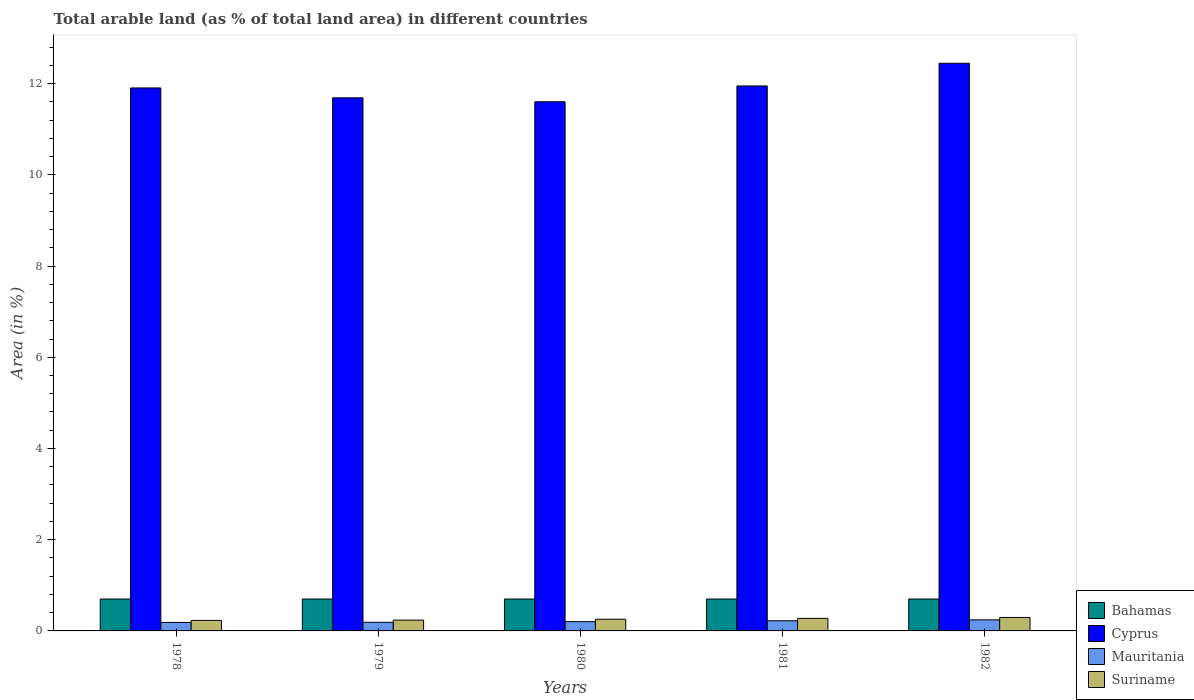How many different coloured bars are there?
Your answer should be very brief. 4. How many bars are there on the 2nd tick from the left?
Ensure brevity in your answer.  4. How many bars are there on the 5th tick from the right?
Your response must be concise. 4. What is the percentage of arable land in Bahamas in 1978?
Provide a succinct answer. 0.7. Across all years, what is the maximum percentage of arable land in Suriname?
Provide a succinct answer. 0.29. Across all years, what is the minimum percentage of arable land in Mauritania?
Your answer should be compact. 0.19. In which year was the percentage of arable land in Mauritania minimum?
Offer a very short reply. 1978. What is the total percentage of arable land in Mauritania in the graph?
Offer a terse response. 1.04. What is the difference between the percentage of arable land in Cyprus in 1979 and that in 1982?
Give a very brief answer. -0.76. What is the difference between the percentage of arable land in Cyprus in 1982 and the percentage of arable land in Mauritania in 1978?
Ensure brevity in your answer.  12.26. What is the average percentage of arable land in Mauritania per year?
Give a very brief answer. 0.21. In the year 1980, what is the difference between the percentage of arable land in Suriname and percentage of arable land in Bahamas?
Your response must be concise. -0.44. What is the difference between the highest and the second highest percentage of arable land in Cyprus?
Your answer should be compact. 0.5. What is the difference between the highest and the lowest percentage of arable land in Bahamas?
Give a very brief answer. 0. Is it the case that in every year, the sum of the percentage of arable land in Bahamas and percentage of arable land in Cyprus is greater than the sum of percentage of arable land in Suriname and percentage of arable land in Mauritania?
Keep it short and to the point. Yes. What does the 2nd bar from the left in 1982 represents?
Provide a short and direct response. Cyprus. What does the 1st bar from the right in 1982 represents?
Your response must be concise. Suriname. Is it the case that in every year, the sum of the percentage of arable land in Suriname and percentage of arable land in Mauritania is greater than the percentage of arable land in Bahamas?
Your response must be concise. No. How many years are there in the graph?
Give a very brief answer. 5. What is the difference between two consecutive major ticks on the Y-axis?
Make the answer very short. 2. Does the graph contain grids?
Your answer should be very brief. No. How many legend labels are there?
Give a very brief answer. 4. How are the legend labels stacked?
Your response must be concise. Vertical. What is the title of the graph?
Provide a short and direct response. Total arable land (as % of total land area) in different countries. What is the label or title of the Y-axis?
Provide a succinct answer. Area (in %). What is the Area (in %) in Bahamas in 1978?
Keep it short and to the point. 0.7. What is the Area (in %) of Cyprus in 1978?
Keep it short and to the point. 11.9. What is the Area (in %) of Mauritania in 1978?
Give a very brief answer. 0.19. What is the Area (in %) in Suriname in 1978?
Provide a succinct answer. 0.23. What is the Area (in %) in Bahamas in 1979?
Your answer should be compact. 0.7. What is the Area (in %) in Cyprus in 1979?
Your answer should be compact. 11.69. What is the Area (in %) of Mauritania in 1979?
Keep it short and to the point. 0.19. What is the Area (in %) in Suriname in 1979?
Your response must be concise. 0.24. What is the Area (in %) of Bahamas in 1980?
Keep it short and to the point. 0.7. What is the Area (in %) of Cyprus in 1980?
Provide a succinct answer. 11.6. What is the Area (in %) in Mauritania in 1980?
Ensure brevity in your answer.  0.2. What is the Area (in %) of Suriname in 1980?
Ensure brevity in your answer.  0.26. What is the Area (in %) of Bahamas in 1981?
Ensure brevity in your answer.  0.7. What is the Area (in %) in Cyprus in 1981?
Your answer should be compact. 11.95. What is the Area (in %) of Mauritania in 1981?
Ensure brevity in your answer.  0.22. What is the Area (in %) of Suriname in 1981?
Make the answer very short. 0.28. What is the Area (in %) of Bahamas in 1982?
Provide a short and direct response. 0.7. What is the Area (in %) of Cyprus in 1982?
Offer a very short reply. 12.45. What is the Area (in %) of Mauritania in 1982?
Your response must be concise. 0.24. What is the Area (in %) of Suriname in 1982?
Keep it short and to the point. 0.29. Across all years, what is the maximum Area (in %) of Bahamas?
Give a very brief answer. 0.7. Across all years, what is the maximum Area (in %) in Cyprus?
Your response must be concise. 12.45. Across all years, what is the maximum Area (in %) in Mauritania?
Your answer should be very brief. 0.24. Across all years, what is the maximum Area (in %) in Suriname?
Offer a terse response. 0.29. Across all years, what is the minimum Area (in %) of Bahamas?
Your answer should be very brief. 0.7. Across all years, what is the minimum Area (in %) of Cyprus?
Offer a terse response. 11.6. Across all years, what is the minimum Area (in %) in Mauritania?
Keep it short and to the point. 0.19. Across all years, what is the minimum Area (in %) in Suriname?
Your answer should be very brief. 0.23. What is the total Area (in %) in Bahamas in the graph?
Make the answer very short. 3.5. What is the total Area (in %) in Cyprus in the graph?
Offer a terse response. 59.59. What is the total Area (in %) of Mauritania in the graph?
Keep it short and to the point. 1.04. What is the total Area (in %) of Suriname in the graph?
Give a very brief answer. 1.29. What is the difference between the Area (in %) in Cyprus in 1978 and that in 1979?
Ensure brevity in your answer.  0.22. What is the difference between the Area (in %) in Mauritania in 1978 and that in 1979?
Make the answer very short. -0. What is the difference between the Area (in %) of Suriname in 1978 and that in 1979?
Make the answer very short. -0.01. What is the difference between the Area (in %) of Bahamas in 1978 and that in 1980?
Ensure brevity in your answer.  0. What is the difference between the Area (in %) in Cyprus in 1978 and that in 1980?
Provide a succinct answer. 0.3. What is the difference between the Area (in %) in Mauritania in 1978 and that in 1980?
Make the answer very short. -0.02. What is the difference between the Area (in %) of Suriname in 1978 and that in 1980?
Your answer should be very brief. -0.03. What is the difference between the Area (in %) in Cyprus in 1978 and that in 1981?
Your response must be concise. -0.04. What is the difference between the Area (in %) in Mauritania in 1978 and that in 1981?
Provide a short and direct response. -0.04. What is the difference between the Area (in %) of Suriname in 1978 and that in 1981?
Your answer should be compact. -0.04. What is the difference between the Area (in %) in Cyprus in 1978 and that in 1982?
Your response must be concise. -0.54. What is the difference between the Area (in %) in Mauritania in 1978 and that in 1982?
Give a very brief answer. -0.06. What is the difference between the Area (in %) in Suriname in 1978 and that in 1982?
Make the answer very short. -0.06. What is the difference between the Area (in %) in Bahamas in 1979 and that in 1980?
Your response must be concise. 0. What is the difference between the Area (in %) in Cyprus in 1979 and that in 1980?
Ensure brevity in your answer.  0.09. What is the difference between the Area (in %) in Mauritania in 1979 and that in 1980?
Your answer should be very brief. -0.01. What is the difference between the Area (in %) of Suriname in 1979 and that in 1980?
Provide a short and direct response. -0.02. What is the difference between the Area (in %) in Cyprus in 1979 and that in 1981?
Offer a terse response. -0.26. What is the difference between the Area (in %) in Mauritania in 1979 and that in 1981?
Offer a terse response. -0.03. What is the difference between the Area (in %) of Suriname in 1979 and that in 1981?
Offer a very short reply. -0.04. What is the difference between the Area (in %) of Cyprus in 1979 and that in 1982?
Your answer should be compact. -0.76. What is the difference between the Area (in %) in Mauritania in 1979 and that in 1982?
Ensure brevity in your answer.  -0.05. What is the difference between the Area (in %) in Suriname in 1979 and that in 1982?
Ensure brevity in your answer.  -0.06. What is the difference between the Area (in %) of Cyprus in 1980 and that in 1981?
Your answer should be very brief. -0.35. What is the difference between the Area (in %) of Mauritania in 1980 and that in 1981?
Your response must be concise. -0.02. What is the difference between the Area (in %) in Suriname in 1980 and that in 1981?
Your response must be concise. -0.02. What is the difference between the Area (in %) in Bahamas in 1980 and that in 1982?
Your answer should be compact. 0. What is the difference between the Area (in %) in Cyprus in 1980 and that in 1982?
Make the answer very short. -0.84. What is the difference between the Area (in %) in Mauritania in 1980 and that in 1982?
Offer a terse response. -0.04. What is the difference between the Area (in %) of Suriname in 1980 and that in 1982?
Offer a very short reply. -0.04. What is the difference between the Area (in %) in Bahamas in 1981 and that in 1982?
Provide a succinct answer. 0. What is the difference between the Area (in %) in Cyprus in 1981 and that in 1982?
Provide a succinct answer. -0.5. What is the difference between the Area (in %) in Mauritania in 1981 and that in 1982?
Provide a short and direct response. -0.02. What is the difference between the Area (in %) in Suriname in 1981 and that in 1982?
Provide a short and direct response. -0.02. What is the difference between the Area (in %) of Bahamas in 1978 and the Area (in %) of Cyprus in 1979?
Your answer should be compact. -10.99. What is the difference between the Area (in %) of Bahamas in 1978 and the Area (in %) of Mauritania in 1979?
Make the answer very short. 0.51. What is the difference between the Area (in %) in Bahamas in 1978 and the Area (in %) in Suriname in 1979?
Make the answer very short. 0.46. What is the difference between the Area (in %) of Cyprus in 1978 and the Area (in %) of Mauritania in 1979?
Give a very brief answer. 11.72. What is the difference between the Area (in %) in Cyprus in 1978 and the Area (in %) in Suriname in 1979?
Keep it short and to the point. 11.67. What is the difference between the Area (in %) of Mauritania in 1978 and the Area (in %) of Suriname in 1979?
Your answer should be very brief. -0.05. What is the difference between the Area (in %) in Bahamas in 1978 and the Area (in %) in Cyprus in 1980?
Your answer should be compact. -10.9. What is the difference between the Area (in %) of Bahamas in 1978 and the Area (in %) of Mauritania in 1980?
Your answer should be compact. 0.5. What is the difference between the Area (in %) of Bahamas in 1978 and the Area (in %) of Suriname in 1980?
Give a very brief answer. 0.44. What is the difference between the Area (in %) in Cyprus in 1978 and the Area (in %) in Mauritania in 1980?
Your response must be concise. 11.7. What is the difference between the Area (in %) in Cyprus in 1978 and the Area (in %) in Suriname in 1980?
Your answer should be very brief. 11.65. What is the difference between the Area (in %) of Mauritania in 1978 and the Area (in %) of Suriname in 1980?
Offer a very short reply. -0.07. What is the difference between the Area (in %) in Bahamas in 1978 and the Area (in %) in Cyprus in 1981?
Ensure brevity in your answer.  -11.25. What is the difference between the Area (in %) in Bahamas in 1978 and the Area (in %) in Mauritania in 1981?
Offer a very short reply. 0.48. What is the difference between the Area (in %) in Bahamas in 1978 and the Area (in %) in Suriname in 1981?
Keep it short and to the point. 0.42. What is the difference between the Area (in %) of Cyprus in 1978 and the Area (in %) of Mauritania in 1981?
Offer a very short reply. 11.68. What is the difference between the Area (in %) in Cyprus in 1978 and the Area (in %) in Suriname in 1981?
Provide a short and direct response. 11.63. What is the difference between the Area (in %) in Mauritania in 1978 and the Area (in %) in Suriname in 1981?
Offer a very short reply. -0.09. What is the difference between the Area (in %) of Bahamas in 1978 and the Area (in %) of Cyprus in 1982?
Give a very brief answer. -11.75. What is the difference between the Area (in %) of Bahamas in 1978 and the Area (in %) of Mauritania in 1982?
Offer a very short reply. 0.46. What is the difference between the Area (in %) of Bahamas in 1978 and the Area (in %) of Suriname in 1982?
Provide a short and direct response. 0.4. What is the difference between the Area (in %) in Cyprus in 1978 and the Area (in %) in Mauritania in 1982?
Your answer should be very brief. 11.66. What is the difference between the Area (in %) in Cyprus in 1978 and the Area (in %) in Suriname in 1982?
Your answer should be very brief. 11.61. What is the difference between the Area (in %) of Mauritania in 1978 and the Area (in %) of Suriname in 1982?
Offer a very short reply. -0.11. What is the difference between the Area (in %) in Bahamas in 1979 and the Area (in %) in Cyprus in 1980?
Your response must be concise. -10.9. What is the difference between the Area (in %) in Bahamas in 1979 and the Area (in %) in Mauritania in 1980?
Provide a succinct answer. 0.5. What is the difference between the Area (in %) of Bahamas in 1979 and the Area (in %) of Suriname in 1980?
Ensure brevity in your answer.  0.44. What is the difference between the Area (in %) in Cyprus in 1979 and the Area (in %) in Mauritania in 1980?
Provide a succinct answer. 11.48. What is the difference between the Area (in %) of Cyprus in 1979 and the Area (in %) of Suriname in 1980?
Give a very brief answer. 11.43. What is the difference between the Area (in %) of Mauritania in 1979 and the Area (in %) of Suriname in 1980?
Offer a terse response. -0.07. What is the difference between the Area (in %) in Bahamas in 1979 and the Area (in %) in Cyprus in 1981?
Keep it short and to the point. -11.25. What is the difference between the Area (in %) in Bahamas in 1979 and the Area (in %) in Mauritania in 1981?
Your answer should be compact. 0.48. What is the difference between the Area (in %) in Bahamas in 1979 and the Area (in %) in Suriname in 1981?
Give a very brief answer. 0.42. What is the difference between the Area (in %) of Cyprus in 1979 and the Area (in %) of Mauritania in 1981?
Provide a succinct answer. 11.47. What is the difference between the Area (in %) in Cyprus in 1979 and the Area (in %) in Suriname in 1981?
Your answer should be compact. 11.41. What is the difference between the Area (in %) of Mauritania in 1979 and the Area (in %) of Suriname in 1981?
Your answer should be very brief. -0.09. What is the difference between the Area (in %) in Bahamas in 1979 and the Area (in %) in Cyprus in 1982?
Keep it short and to the point. -11.75. What is the difference between the Area (in %) of Bahamas in 1979 and the Area (in %) of Mauritania in 1982?
Give a very brief answer. 0.46. What is the difference between the Area (in %) in Bahamas in 1979 and the Area (in %) in Suriname in 1982?
Give a very brief answer. 0.4. What is the difference between the Area (in %) of Cyprus in 1979 and the Area (in %) of Mauritania in 1982?
Offer a very short reply. 11.45. What is the difference between the Area (in %) of Cyprus in 1979 and the Area (in %) of Suriname in 1982?
Give a very brief answer. 11.39. What is the difference between the Area (in %) of Mauritania in 1979 and the Area (in %) of Suriname in 1982?
Keep it short and to the point. -0.11. What is the difference between the Area (in %) of Bahamas in 1980 and the Area (in %) of Cyprus in 1981?
Offer a terse response. -11.25. What is the difference between the Area (in %) in Bahamas in 1980 and the Area (in %) in Mauritania in 1981?
Make the answer very short. 0.48. What is the difference between the Area (in %) of Bahamas in 1980 and the Area (in %) of Suriname in 1981?
Offer a very short reply. 0.42. What is the difference between the Area (in %) of Cyprus in 1980 and the Area (in %) of Mauritania in 1981?
Offer a very short reply. 11.38. What is the difference between the Area (in %) in Cyprus in 1980 and the Area (in %) in Suriname in 1981?
Offer a terse response. 11.33. What is the difference between the Area (in %) in Mauritania in 1980 and the Area (in %) in Suriname in 1981?
Make the answer very short. -0.07. What is the difference between the Area (in %) in Bahamas in 1980 and the Area (in %) in Cyprus in 1982?
Your answer should be very brief. -11.75. What is the difference between the Area (in %) of Bahamas in 1980 and the Area (in %) of Mauritania in 1982?
Your answer should be very brief. 0.46. What is the difference between the Area (in %) of Bahamas in 1980 and the Area (in %) of Suriname in 1982?
Offer a terse response. 0.4. What is the difference between the Area (in %) of Cyprus in 1980 and the Area (in %) of Mauritania in 1982?
Keep it short and to the point. 11.36. What is the difference between the Area (in %) of Cyprus in 1980 and the Area (in %) of Suriname in 1982?
Offer a terse response. 11.31. What is the difference between the Area (in %) in Mauritania in 1980 and the Area (in %) in Suriname in 1982?
Provide a short and direct response. -0.09. What is the difference between the Area (in %) in Bahamas in 1981 and the Area (in %) in Cyprus in 1982?
Give a very brief answer. -11.75. What is the difference between the Area (in %) in Bahamas in 1981 and the Area (in %) in Mauritania in 1982?
Make the answer very short. 0.46. What is the difference between the Area (in %) of Bahamas in 1981 and the Area (in %) of Suriname in 1982?
Your answer should be very brief. 0.4. What is the difference between the Area (in %) of Cyprus in 1981 and the Area (in %) of Mauritania in 1982?
Your answer should be compact. 11.71. What is the difference between the Area (in %) in Cyprus in 1981 and the Area (in %) in Suriname in 1982?
Provide a succinct answer. 11.65. What is the difference between the Area (in %) in Mauritania in 1981 and the Area (in %) in Suriname in 1982?
Ensure brevity in your answer.  -0.07. What is the average Area (in %) in Bahamas per year?
Offer a very short reply. 0.7. What is the average Area (in %) in Cyprus per year?
Give a very brief answer. 11.92. What is the average Area (in %) of Mauritania per year?
Keep it short and to the point. 0.21. What is the average Area (in %) of Suriname per year?
Your answer should be very brief. 0.26. In the year 1978, what is the difference between the Area (in %) of Bahamas and Area (in %) of Cyprus?
Make the answer very short. -11.21. In the year 1978, what is the difference between the Area (in %) of Bahamas and Area (in %) of Mauritania?
Ensure brevity in your answer.  0.51. In the year 1978, what is the difference between the Area (in %) in Bahamas and Area (in %) in Suriname?
Make the answer very short. 0.47. In the year 1978, what is the difference between the Area (in %) of Cyprus and Area (in %) of Mauritania?
Offer a terse response. 11.72. In the year 1978, what is the difference between the Area (in %) of Cyprus and Area (in %) of Suriname?
Offer a very short reply. 11.67. In the year 1978, what is the difference between the Area (in %) of Mauritania and Area (in %) of Suriname?
Your answer should be compact. -0.04. In the year 1979, what is the difference between the Area (in %) in Bahamas and Area (in %) in Cyprus?
Offer a terse response. -10.99. In the year 1979, what is the difference between the Area (in %) of Bahamas and Area (in %) of Mauritania?
Offer a terse response. 0.51. In the year 1979, what is the difference between the Area (in %) of Bahamas and Area (in %) of Suriname?
Your answer should be compact. 0.46. In the year 1979, what is the difference between the Area (in %) in Cyprus and Area (in %) in Mauritania?
Your response must be concise. 11.5. In the year 1979, what is the difference between the Area (in %) in Cyprus and Area (in %) in Suriname?
Ensure brevity in your answer.  11.45. In the year 1979, what is the difference between the Area (in %) of Mauritania and Area (in %) of Suriname?
Ensure brevity in your answer.  -0.05. In the year 1980, what is the difference between the Area (in %) in Bahamas and Area (in %) in Cyprus?
Give a very brief answer. -10.9. In the year 1980, what is the difference between the Area (in %) of Bahamas and Area (in %) of Mauritania?
Ensure brevity in your answer.  0.5. In the year 1980, what is the difference between the Area (in %) of Bahamas and Area (in %) of Suriname?
Make the answer very short. 0.44. In the year 1980, what is the difference between the Area (in %) in Cyprus and Area (in %) in Mauritania?
Provide a short and direct response. 11.4. In the year 1980, what is the difference between the Area (in %) of Cyprus and Area (in %) of Suriname?
Provide a short and direct response. 11.35. In the year 1980, what is the difference between the Area (in %) of Mauritania and Area (in %) of Suriname?
Your answer should be very brief. -0.05. In the year 1981, what is the difference between the Area (in %) of Bahamas and Area (in %) of Cyprus?
Provide a short and direct response. -11.25. In the year 1981, what is the difference between the Area (in %) of Bahamas and Area (in %) of Mauritania?
Give a very brief answer. 0.48. In the year 1981, what is the difference between the Area (in %) in Bahamas and Area (in %) in Suriname?
Offer a very short reply. 0.42. In the year 1981, what is the difference between the Area (in %) of Cyprus and Area (in %) of Mauritania?
Offer a very short reply. 11.72. In the year 1981, what is the difference between the Area (in %) of Cyprus and Area (in %) of Suriname?
Your answer should be compact. 11.67. In the year 1981, what is the difference between the Area (in %) in Mauritania and Area (in %) in Suriname?
Offer a very short reply. -0.05. In the year 1982, what is the difference between the Area (in %) in Bahamas and Area (in %) in Cyprus?
Ensure brevity in your answer.  -11.75. In the year 1982, what is the difference between the Area (in %) of Bahamas and Area (in %) of Mauritania?
Offer a terse response. 0.46. In the year 1982, what is the difference between the Area (in %) of Bahamas and Area (in %) of Suriname?
Make the answer very short. 0.4. In the year 1982, what is the difference between the Area (in %) of Cyprus and Area (in %) of Mauritania?
Give a very brief answer. 12.2. In the year 1982, what is the difference between the Area (in %) in Cyprus and Area (in %) in Suriname?
Keep it short and to the point. 12.15. In the year 1982, what is the difference between the Area (in %) in Mauritania and Area (in %) in Suriname?
Your answer should be very brief. -0.05. What is the ratio of the Area (in %) of Bahamas in 1978 to that in 1979?
Your response must be concise. 1. What is the ratio of the Area (in %) in Cyprus in 1978 to that in 1979?
Give a very brief answer. 1.02. What is the ratio of the Area (in %) of Mauritania in 1978 to that in 1979?
Give a very brief answer. 0.98. What is the ratio of the Area (in %) in Suriname in 1978 to that in 1979?
Make the answer very short. 0.97. What is the ratio of the Area (in %) in Cyprus in 1978 to that in 1980?
Your answer should be very brief. 1.03. What is the ratio of the Area (in %) in Mauritania in 1978 to that in 1980?
Make the answer very short. 0.91. What is the ratio of the Area (in %) of Bahamas in 1978 to that in 1981?
Provide a succinct answer. 1. What is the ratio of the Area (in %) in Mauritania in 1978 to that in 1981?
Your answer should be compact. 0.83. What is the ratio of the Area (in %) in Suriname in 1978 to that in 1981?
Your answer should be very brief. 0.84. What is the ratio of the Area (in %) in Bahamas in 1978 to that in 1982?
Offer a terse response. 1. What is the ratio of the Area (in %) of Cyprus in 1978 to that in 1982?
Offer a terse response. 0.96. What is the ratio of the Area (in %) of Mauritania in 1978 to that in 1982?
Offer a terse response. 0.77. What is the ratio of the Area (in %) of Suriname in 1978 to that in 1982?
Your answer should be compact. 0.78. What is the ratio of the Area (in %) of Bahamas in 1979 to that in 1980?
Your answer should be compact. 1. What is the ratio of the Area (in %) of Cyprus in 1979 to that in 1980?
Your answer should be compact. 1.01. What is the ratio of the Area (in %) in Mauritania in 1979 to that in 1980?
Your answer should be very brief. 0.93. What is the ratio of the Area (in %) in Suriname in 1979 to that in 1980?
Offer a very short reply. 0.93. What is the ratio of the Area (in %) of Cyprus in 1979 to that in 1981?
Make the answer very short. 0.98. What is the ratio of the Area (in %) in Mauritania in 1979 to that in 1981?
Make the answer very short. 0.85. What is the ratio of the Area (in %) of Suriname in 1979 to that in 1981?
Your response must be concise. 0.86. What is the ratio of the Area (in %) of Cyprus in 1979 to that in 1982?
Your response must be concise. 0.94. What is the ratio of the Area (in %) of Mauritania in 1979 to that in 1982?
Your response must be concise. 0.78. What is the ratio of the Area (in %) of Suriname in 1979 to that in 1982?
Make the answer very short. 0.8. What is the ratio of the Area (in %) in Bahamas in 1980 to that in 1981?
Offer a terse response. 1. What is the ratio of the Area (in %) of Suriname in 1980 to that in 1981?
Keep it short and to the point. 0.93. What is the ratio of the Area (in %) of Bahamas in 1980 to that in 1982?
Ensure brevity in your answer.  1. What is the ratio of the Area (in %) in Cyprus in 1980 to that in 1982?
Give a very brief answer. 0.93. What is the ratio of the Area (in %) of Mauritania in 1980 to that in 1982?
Provide a short and direct response. 0.84. What is the ratio of the Area (in %) of Suriname in 1980 to that in 1982?
Provide a succinct answer. 0.87. What is the ratio of the Area (in %) in Bahamas in 1981 to that in 1982?
Offer a terse response. 1. What is the ratio of the Area (in %) in Mauritania in 1981 to that in 1982?
Provide a short and direct response. 0.92. What is the ratio of the Area (in %) in Suriname in 1981 to that in 1982?
Make the answer very short. 0.93. What is the difference between the highest and the second highest Area (in %) of Cyprus?
Provide a succinct answer. 0.5. What is the difference between the highest and the second highest Area (in %) in Mauritania?
Give a very brief answer. 0.02. What is the difference between the highest and the second highest Area (in %) of Suriname?
Make the answer very short. 0.02. What is the difference between the highest and the lowest Area (in %) in Bahamas?
Your response must be concise. 0. What is the difference between the highest and the lowest Area (in %) in Cyprus?
Ensure brevity in your answer.  0.84. What is the difference between the highest and the lowest Area (in %) in Mauritania?
Make the answer very short. 0.06. What is the difference between the highest and the lowest Area (in %) in Suriname?
Make the answer very short. 0.06. 